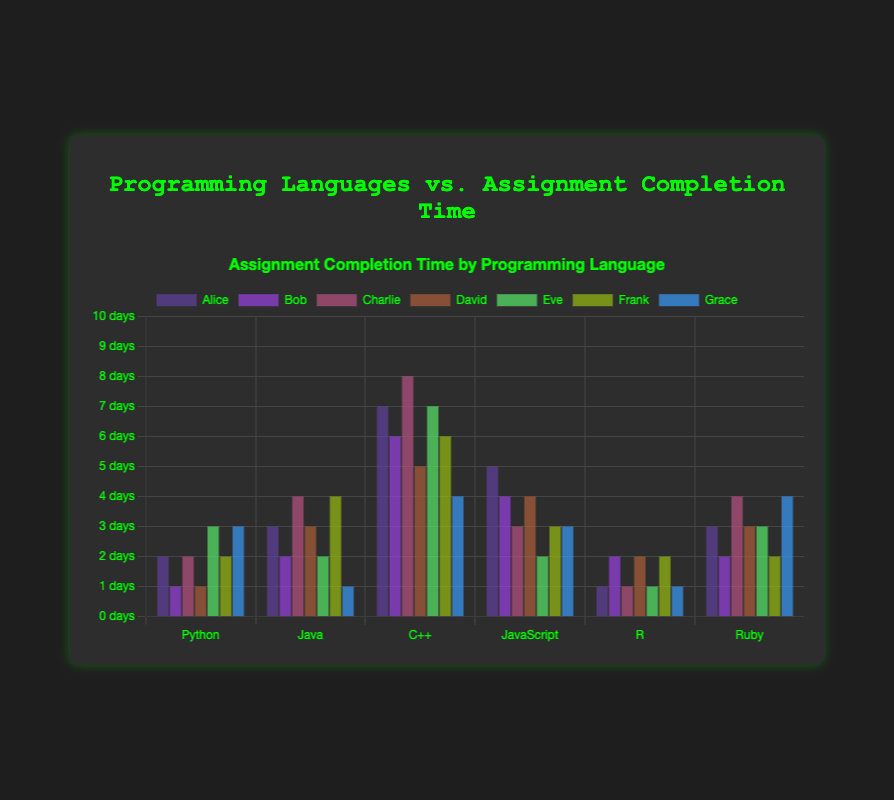Which student completes Python assignments the earliest? Grace completes Python assignments 3 days before the due date. This is the highest value among the Python bars.
Answer: Grace Who spends the most days in advance to complete C++ assignments? Charlie completes C++ assignments 8 days before the due date. This is the highest value among the C++ bars.
Answer: Charlie On average, how many days before the due date does Alice complete her assignments? Sum Alice's completion days (2+3+7+5+1+3) = 21. Divide by the number of languages, 21/6 = 3.5
Answer: 3.5 Compare the days Bob and David spend to complete JavaScript assignments. Who completes earlier and by how many days? Bob completes JavaScript assignments in 4 days, and David in 4 days. Bob completes the same as David.
Answer: 0 days For Ruby assignments, which student completes them the most lately? Both Bob and Frank complete Ruby assignments 2 days before the due date, which is the least among Ruby bars.
Answer: Bob, Frank For assignments done in R, what is the total number of days students take to complete them before the due date? Sum of R bars for all students (1+2+1+2+1+2+1) = 10 days
Answer: 10 days Who is faster: Alice in Java assignments or Grace in Java assignments? Alice takes 3 days, and Grace takes 1 day. Grace is faster by 2 days.
Answer: Grace Calculate the difference between the earliest and latest completion times for JavaScript assignments. The earliest for JavaScript is 2 days (Eve) and the latest is 5 days (Alice). 5 - 2 = 3 days difference.
Answer: 3 days Which student shows the broadest range in completion times across all programming languages? Calculate the range for each student: 
- Alice (7-1=6)
- Bob (6-1=5)
- Charlie (8-1=7)
- David (5-1=4)
- Eve (7-1=6)
- Frank (6-2=4)
- Grace (4-1=3)
Charlie's range (7) is the broadest.
Answer: Charlie 